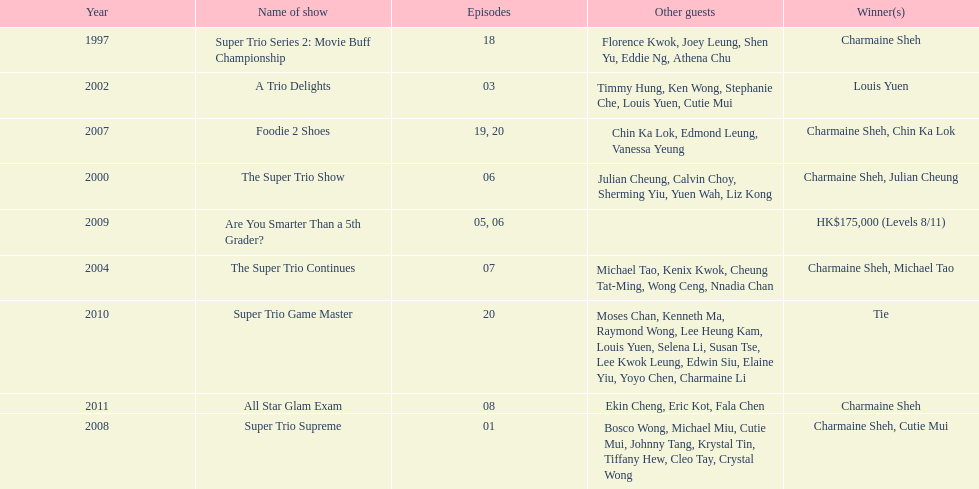Would you be able to parse every entry in this table? {'header': ['Year', 'Name of show', 'Episodes', 'Other guests', 'Winner(s)'], 'rows': [['1997', 'Super Trio Series 2: Movie Buff Championship', '18', 'Florence Kwok, Joey Leung, Shen Yu, Eddie Ng, Athena Chu', 'Charmaine Sheh'], ['2002', 'A Trio Delights', '03', 'Timmy Hung, Ken Wong, Stephanie Che, Louis Yuen, Cutie Mui', 'Louis Yuen'], ['2007', 'Foodie 2 Shoes', '19, 20', 'Chin Ka Lok, Edmond Leung, Vanessa Yeung', 'Charmaine Sheh, Chin Ka Lok'], ['2000', 'The Super Trio Show', '06', 'Julian Cheung, Calvin Choy, Sherming Yiu, Yuen Wah, Liz Kong', 'Charmaine Sheh, Julian Cheung'], ['2009', 'Are You Smarter Than a 5th Grader?', '05, 06', '', 'HK$175,000 (Levels 8/11)'], ['2004', 'The Super Trio Continues', '07', 'Michael Tao, Kenix Kwok, Cheung Tat-Ming, Wong Ceng, Nnadia Chan', 'Charmaine Sheh, Michael Tao'], ['2010', 'Super Trio Game Master', '20', 'Moses Chan, Kenneth Ma, Raymond Wong, Lee Heung Kam, Louis Yuen, Selena Li, Susan Tse, Lee Kwok Leung, Edwin Siu, Elaine Yiu, Yoyo Chen, Charmaine Li', 'Tie'], ['2011', 'All Star Glam Exam', '08', 'Ekin Cheng, Eric Kot, Fala Chen', 'Charmaine Sheh'], ['2008', 'Super Trio Supreme', '01', 'Bosco Wong, Michael Miu, Cutie Mui, Johnny Tang, Krystal Tin, Tiffany Hew, Cleo Tay, Crystal Wong', 'Charmaine Sheh, Cutie Mui']]} How many times has charmaine sheh won on a variety show? 6. 